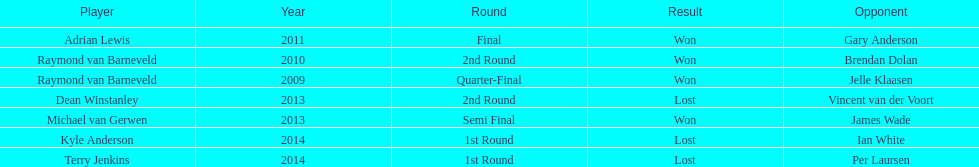What was the names of all the players? Raymond van Barneveld, Raymond van Barneveld, Adrian Lewis, Dean Winstanley, Michael van Gerwen, Terry Jenkins, Kyle Anderson. What years were the championship offered? 2009, 2010, 2011, 2013, 2013, 2014, 2014. Of these, who played in 2011? Adrian Lewis. 